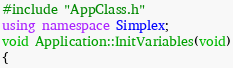Convert code to text. <code><loc_0><loc_0><loc_500><loc_500><_C++_>#include "AppClass.h"
using namespace Simplex;
void Application::InitVariables(void)
{</code> 